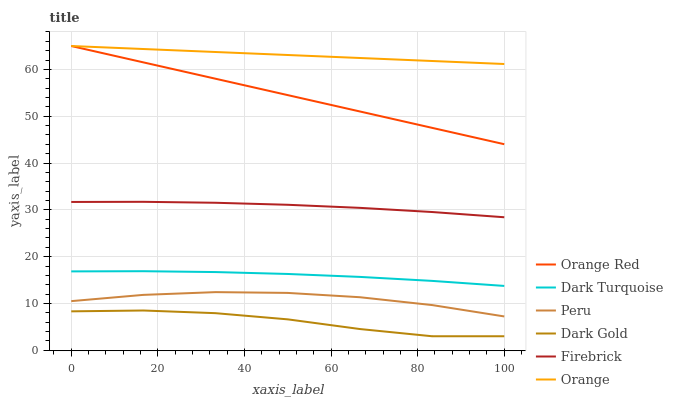Does Dark Gold have the minimum area under the curve?
Answer yes or no. Yes. Does Orange have the maximum area under the curve?
Answer yes or no. Yes. Does Dark Turquoise have the minimum area under the curve?
Answer yes or no. No. Does Dark Turquoise have the maximum area under the curve?
Answer yes or no. No. Is Orange Red the smoothest?
Answer yes or no. Yes. Is Dark Gold the roughest?
Answer yes or no. Yes. Is Dark Turquoise the smoothest?
Answer yes or no. No. Is Dark Turquoise the roughest?
Answer yes or no. No. Does Dark Gold have the lowest value?
Answer yes or no. Yes. Does Dark Turquoise have the lowest value?
Answer yes or no. No. Does Orange Red have the highest value?
Answer yes or no. Yes. Does Dark Turquoise have the highest value?
Answer yes or no. No. Is Peru less than Orange Red?
Answer yes or no. Yes. Is Orange greater than Peru?
Answer yes or no. Yes. Does Orange intersect Orange Red?
Answer yes or no. Yes. Is Orange less than Orange Red?
Answer yes or no. No. Is Orange greater than Orange Red?
Answer yes or no. No. Does Peru intersect Orange Red?
Answer yes or no. No. 